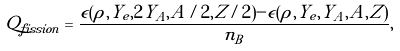<formula> <loc_0><loc_0><loc_500><loc_500>Q _ { f i s s i o n } = \frac { \epsilon ( \rho , Y _ { e } , 2 Y _ { A } , A / 2 , Z / 2 ) - \epsilon ( \rho , Y _ { e } , Y _ { A } , A , Z ) } { n _ { B } } ,</formula> 